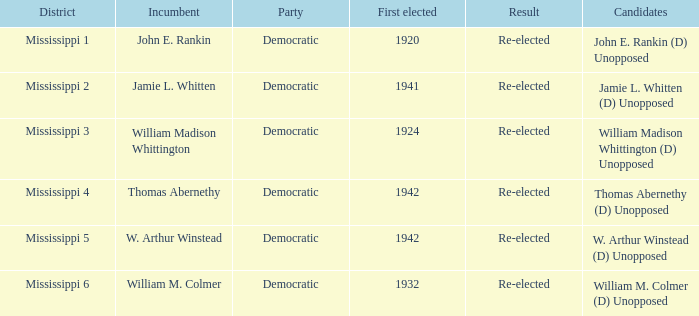What is the finding for w. arthur winstead? Re-elected. 